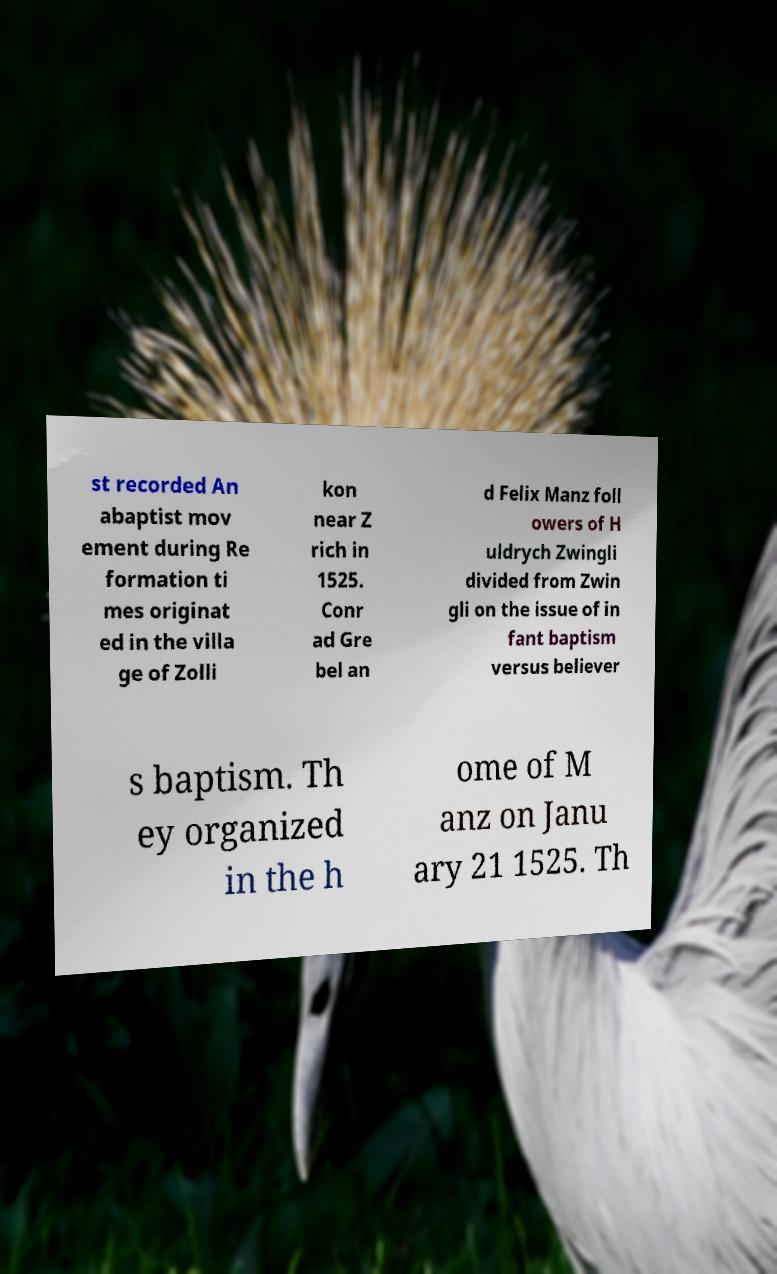Please read and relay the text visible in this image. What does it say? st recorded An abaptist mov ement during Re formation ti mes originat ed in the villa ge of Zolli kon near Z rich in 1525. Conr ad Gre bel an d Felix Manz foll owers of H uldrych Zwingli divided from Zwin gli on the issue of in fant baptism versus believer s baptism. Th ey organized in the h ome of M anz on Janu ary 21 1525. Th 